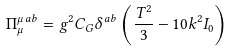<formula> <loc_0><loc_0><loc_500><loc_500>\Pi _ { \mu } ^ { \mu \, a b } = g ^ { 2 } C _ { G } \delta ^ { a b } \left ( \frac { T ^ { 2 } } { 3 } - 1 0 k ^ { 2 } I _ { 0 } \right )</formula> 